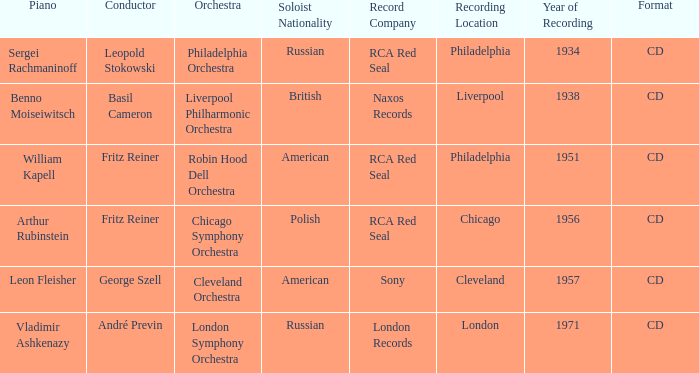Where is the orchestra when the year of recording is 1934? Philadelphia Orchestra. 